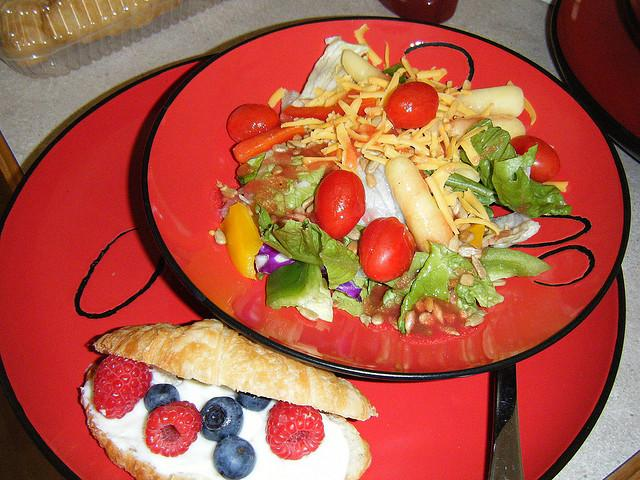How many items qualify as a berry botanically? two 